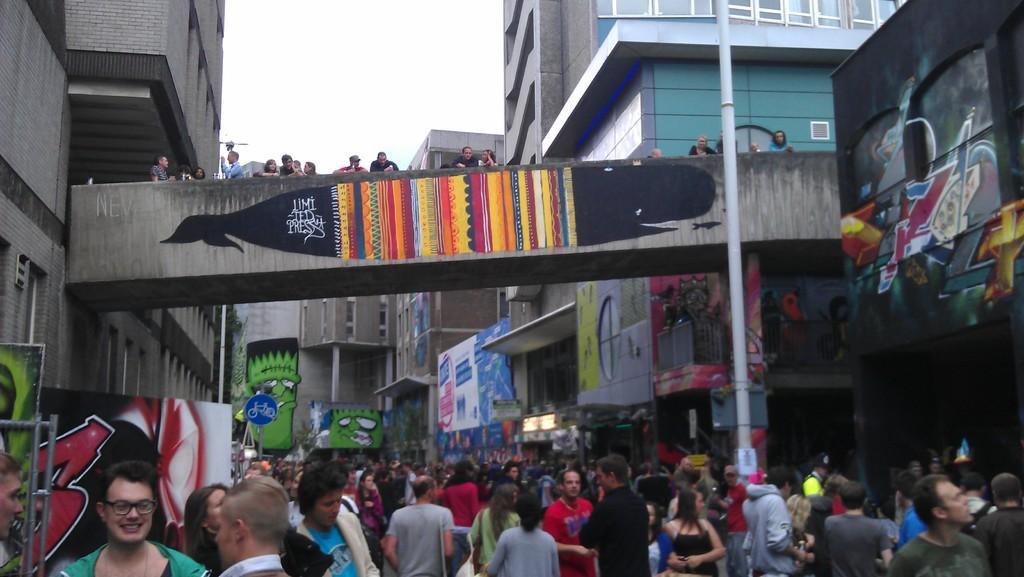In one or two sentences, can you explain what this image depicts? This image consists of many people. On the left and right, there are buildings. And we can see the paintings on the wall. At the top, it looks like a bridge. On which there are few persons. On the right, we can see a pole. At the top, there is sky. 